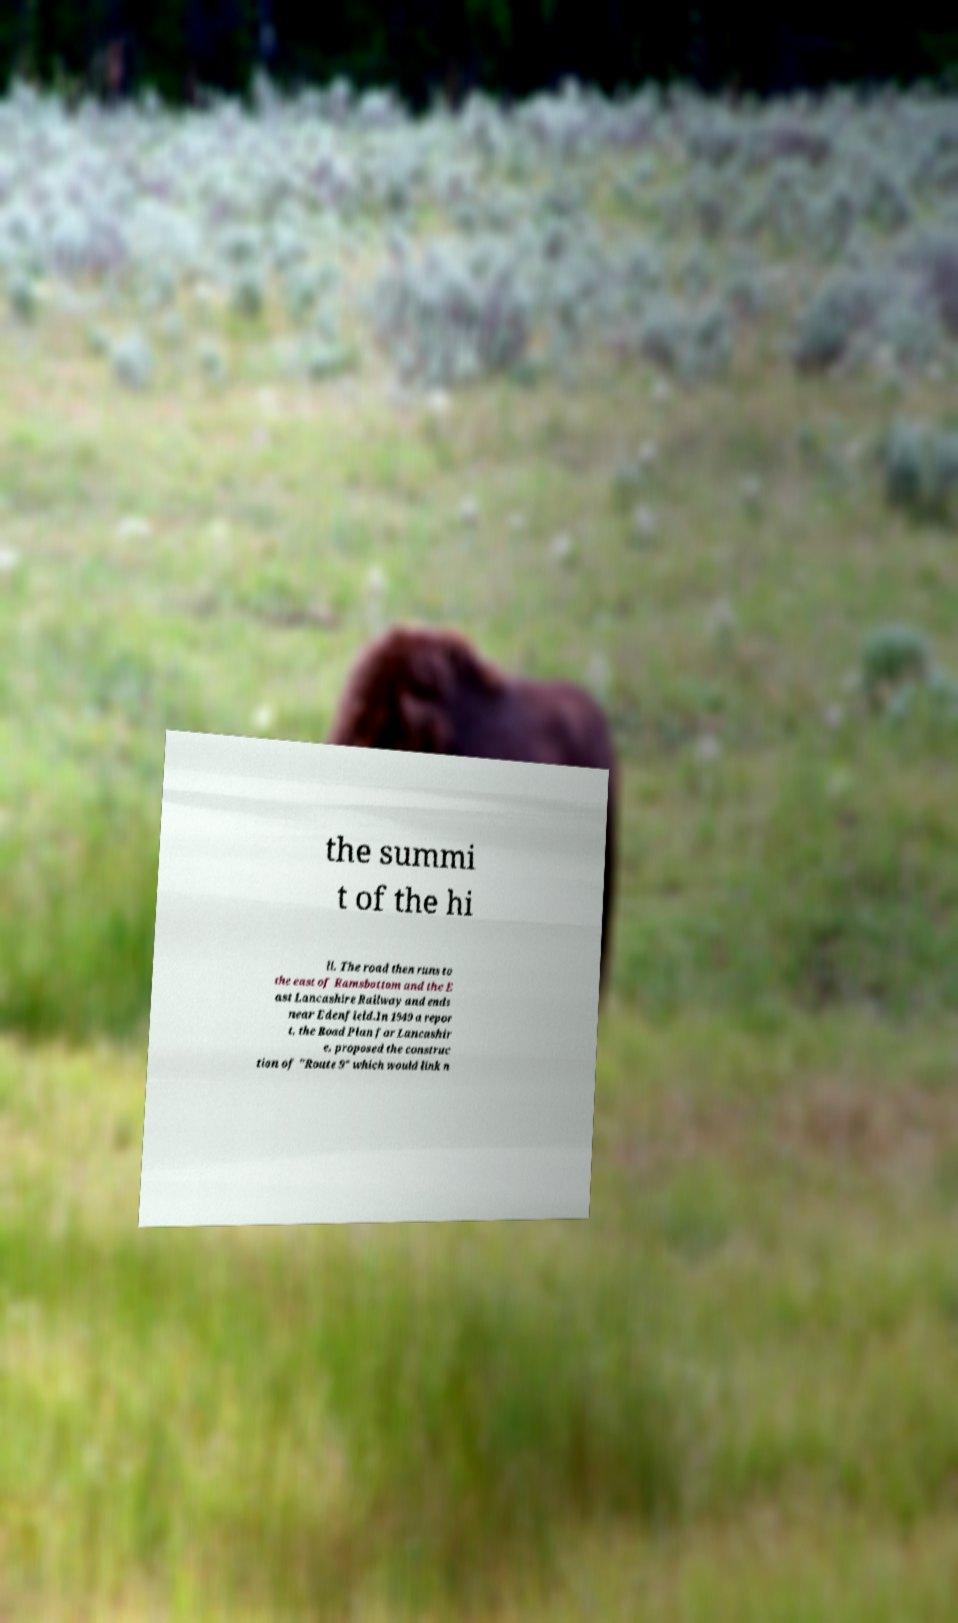Can you accurately transcribe the text from the provided image for me? the summi t of the hi ll. The road then runs to the east of Ramsbottom and the E ast Lancashire Railway and ends near Edenfield.In 1949 a repor t, the Road Plan for Lancashir e, proposed the construc tion of "Route 9" which would link n 